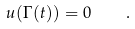<formula> <loc_0><loc_0><loc_500><loc_500>u ( \Gamma ( t ) ) = 0 \quad .</formula> 